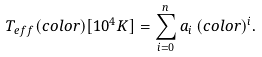<formula> <loc_0><loc_0><loc_500><loc_500>T _ { e f f } ( c o l o r ) [ 1 0 ^ { 4 } K ] = \sum _ { i = 0 } ^ { n } a _ { i } \, ( c o l o r ) ^ { i } .</formula> 